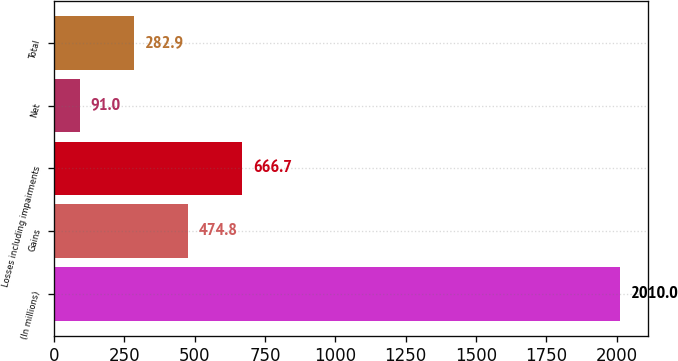Convert chart to OTSL. <chart><loc_0><loc_0><loc_500><loc_500><bar_chart><fcel>(In millions)<fcel>Gains<fcel>Losses including impairments<fcel>Net<fcel>Total<nl><fcel>2010<fcel>474.8<fcel>666.7<fcel>91<fcel>282.9<nl></chart> 